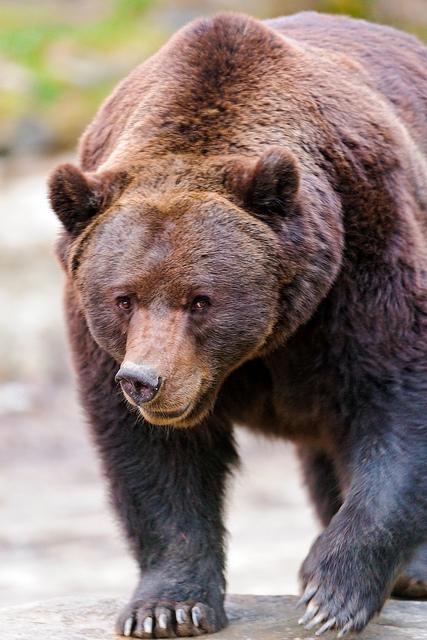Is this animal an adult?
Quick response, please. Yes. Is this animal looking up?
Write a very short answer. No. Does the bear have claws?
Keep it brief. Yes. Is the bear black or brown?
Concise answer only. Brown. Is the bear running?
Keep it brief. No. 